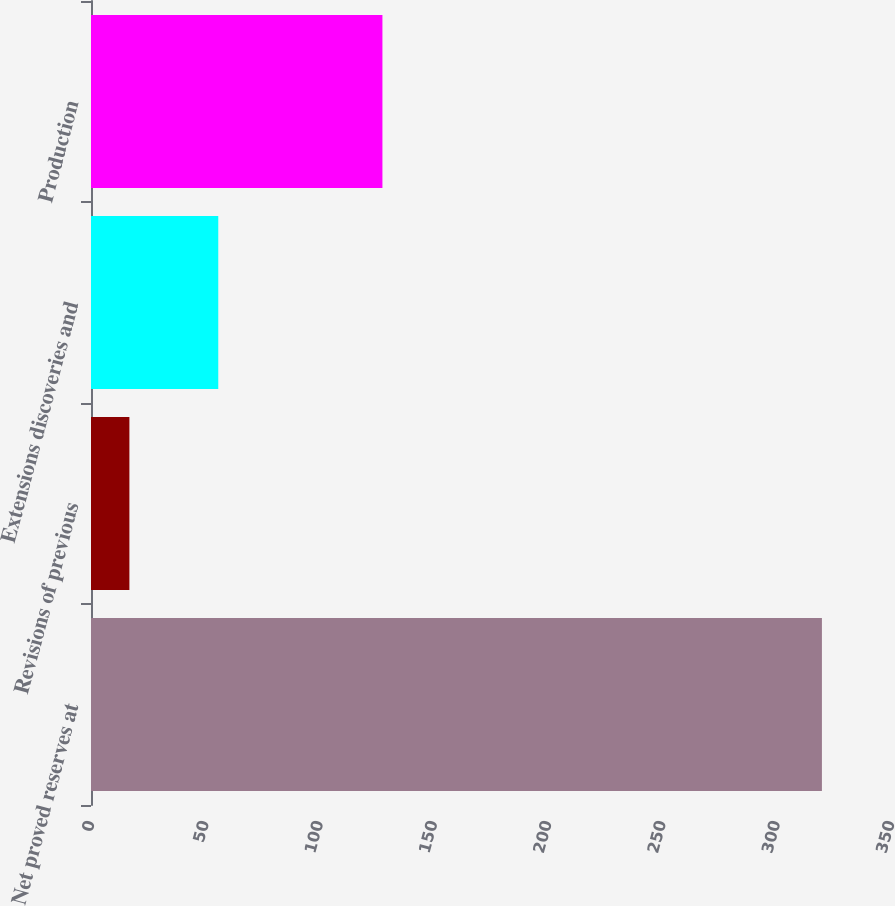Convert chart to OTSL. <chart><loc_0><loc_0><loc_500><loc_500><bar_chart><fcel>Net proved reserves at<fcel>Revisions of previous<fcel>Extensions discoveries and<fcel>Production<nl><fcel>319.78<fcel>16.8<fcel>55.68<fcel>127.5<nl></chart> 